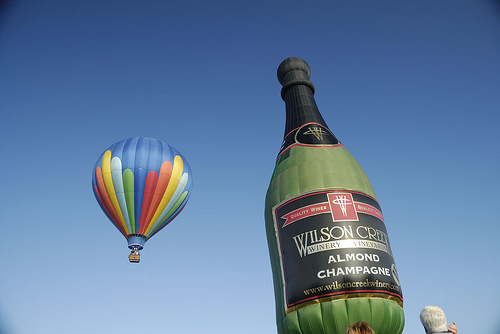<image>
Is the bottle to the right of the balloon? Yes. From this viewpoint, the bottle is positioned to the right side relative to the balloon. Is the wine bottle next to the person? Yes. The wine bottle is positioned adjacent to the person, located nearby in the same general area. Is there a air balloon in front of the air balloon? No. The air balloon is not in front of the air balloon. The spatial positioning shows a different relationship between these objects. 